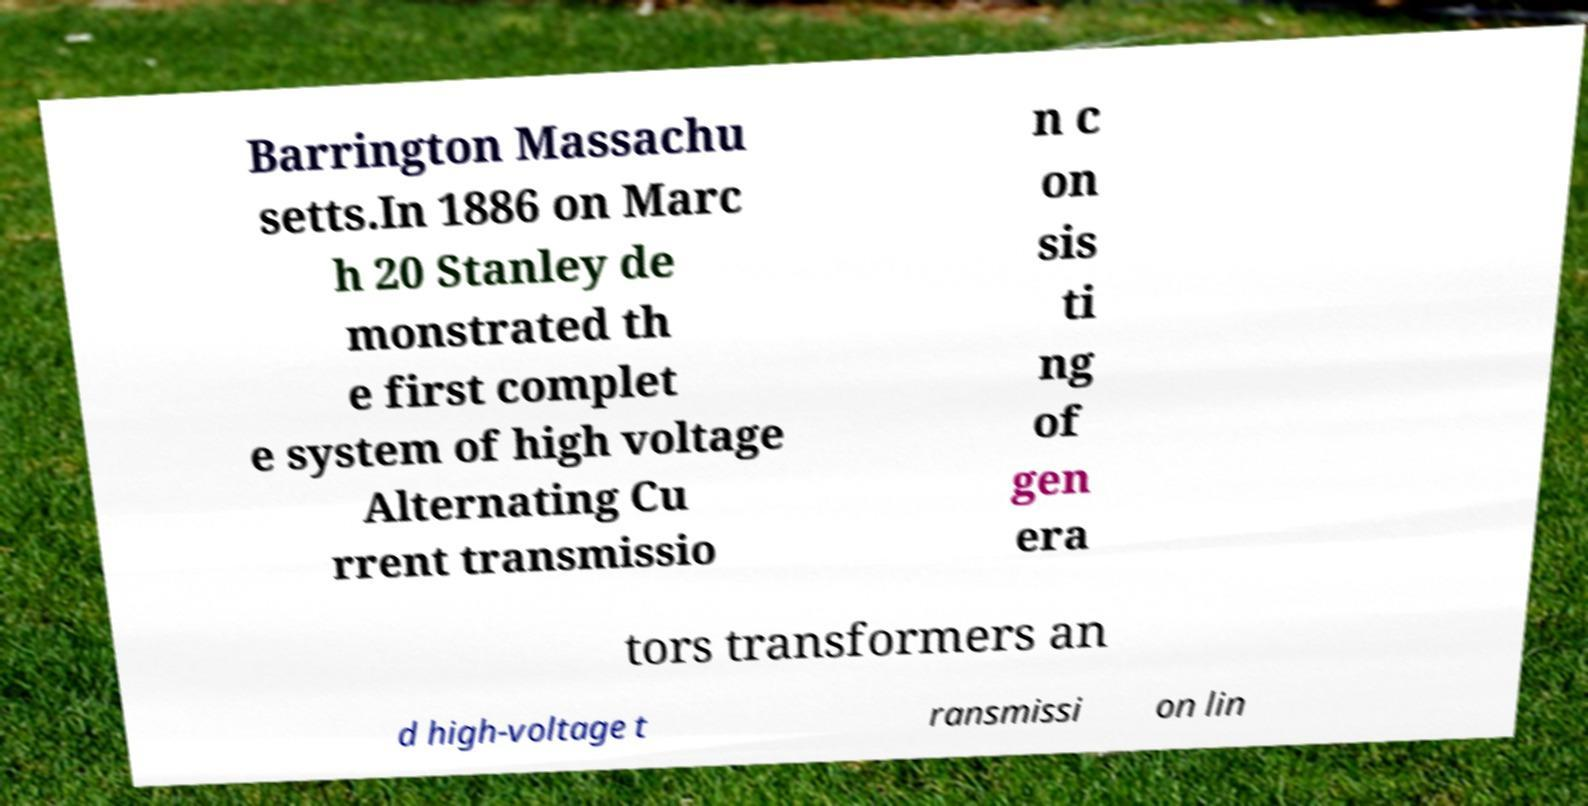Could you assist in decoding the text presented in this image and type it out clearly? Barrington Massachu setts.In 1886 on Marc h 20 Stanley de monstrated th e first complet e system of high voltage Alternating Cu rrent transmissio n c on sis ti ng of gen era tors transformers an d high-voltage t ransmissi on lin 